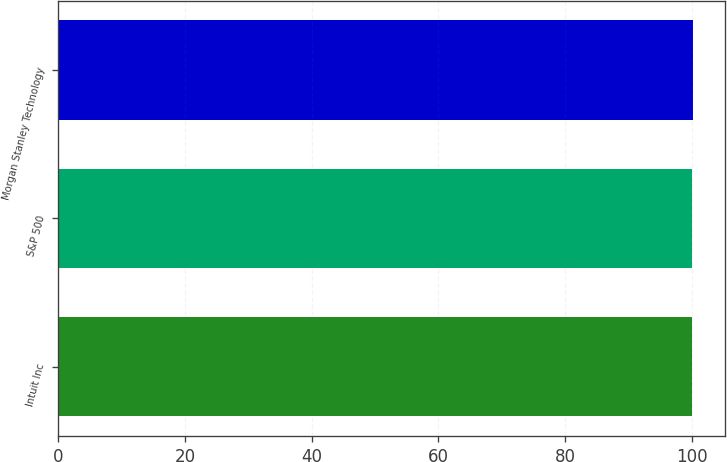Convert chart to OTSL. <chart><loc_0><loc_0><loc_500><loc_500><bar_chart><fcel>Intuit Inc<fcel>S&P 500<fcel>Morgan Stanley Technology<nl><fcel>100<fcel>100.1<fcel>100.2<nl></chart> 